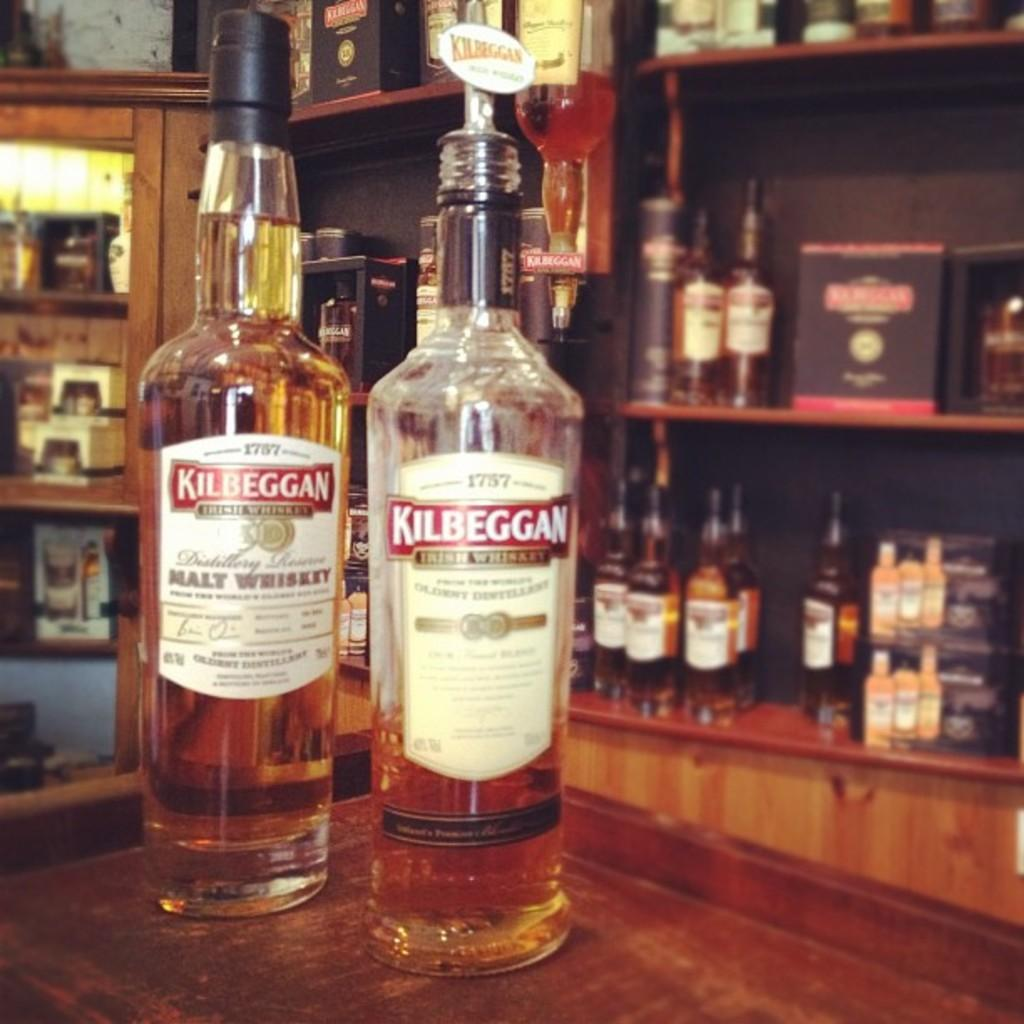<image>
Summarize the visual content of the image. Two Kilbeggan bottles next to each other on top of a table. 